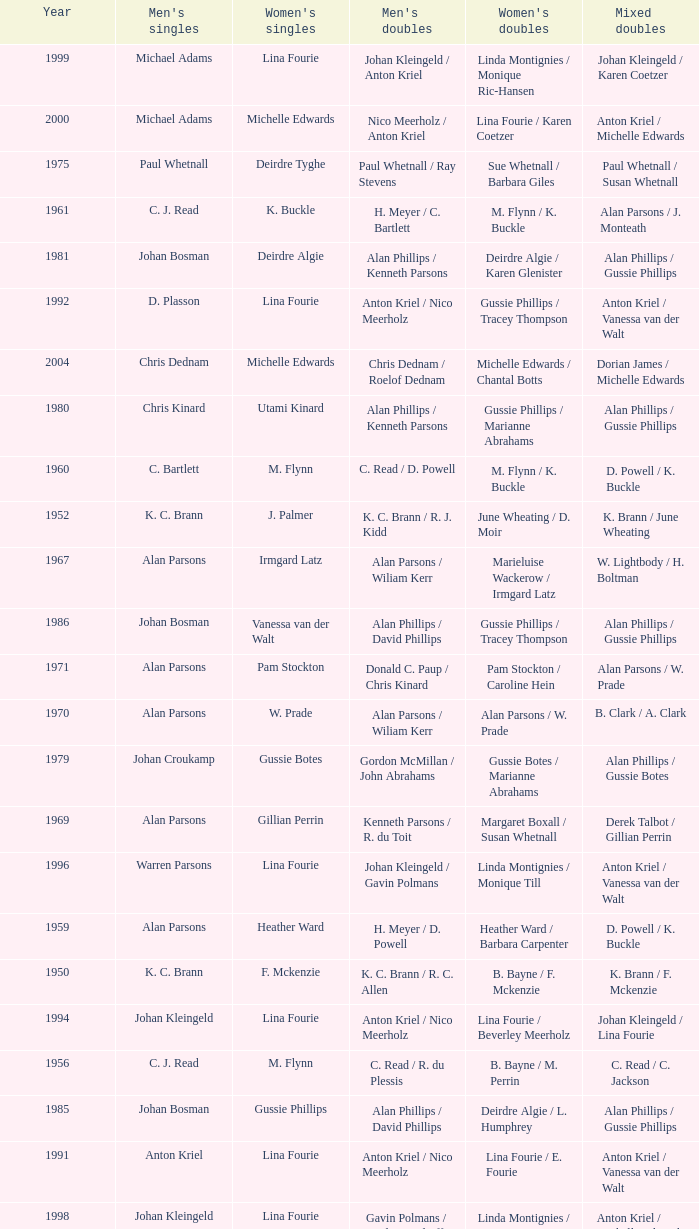Which Men's doubles have a Year smaller than 1960, and Men's singles of noel b. radford? R. C. Allen / E. S. Irwin. 